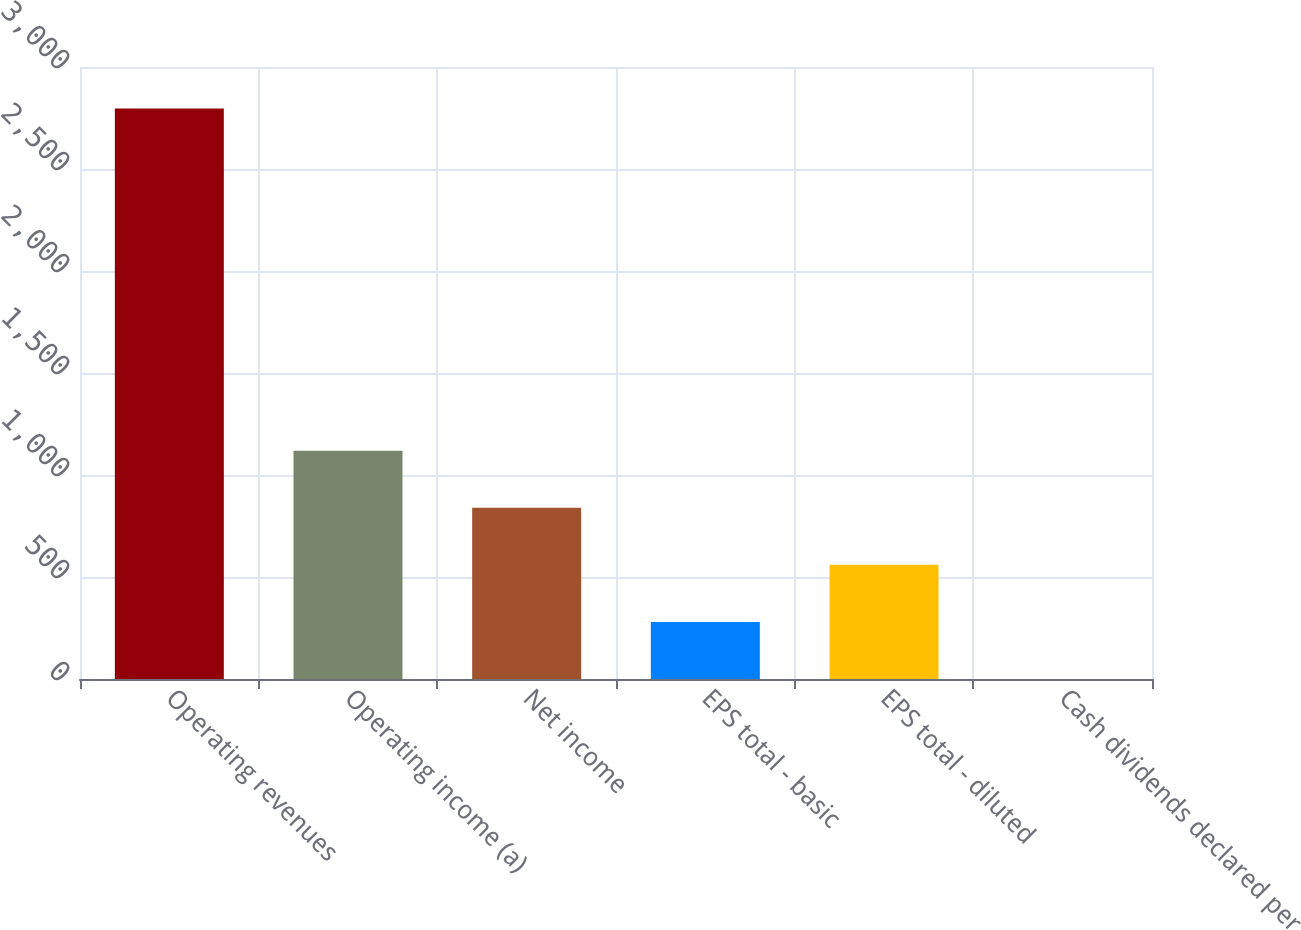Convert chart. <chart><loc_0><loc_0><loc_500><loc_500><bar_chart><fcel>Operating revenues<fcel>Operating income (a)<fcel>Net income<fcel>EPS total - basic<fcel>EPS total - diluted<fcel>Cash dividends declared per<nl><fcel>2796<fcel>1118.6<fcel>839.04<fcel>279.92<fcel>559.48<fcel>0.36<nl></chart> 